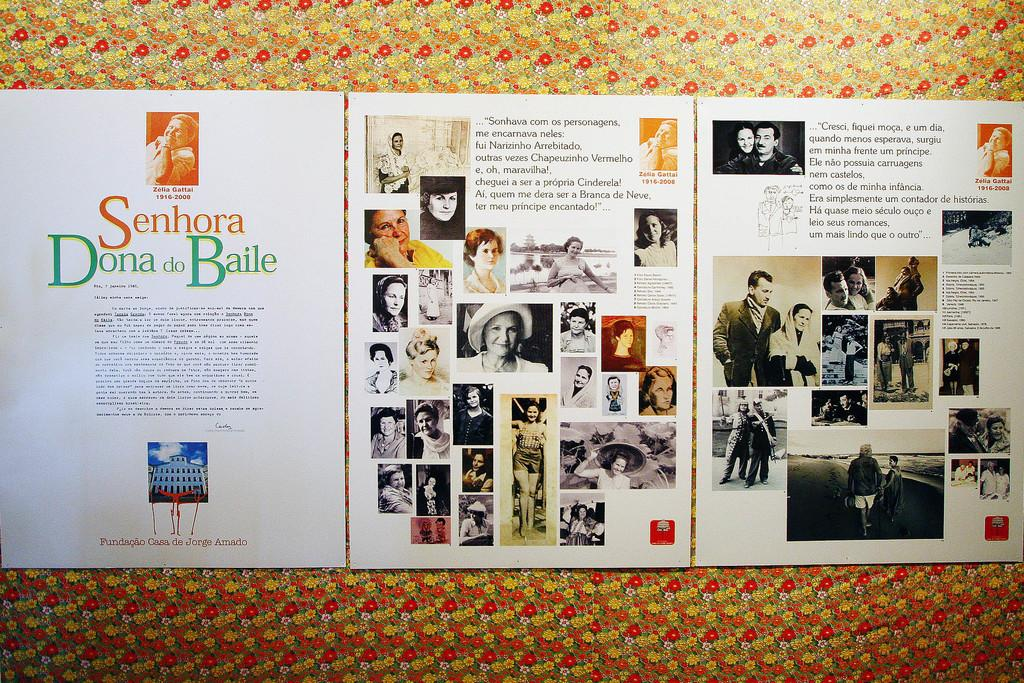Provide a one-sentence caption for the provided image. A paper that has the words Senhor Dona Baile on it. 